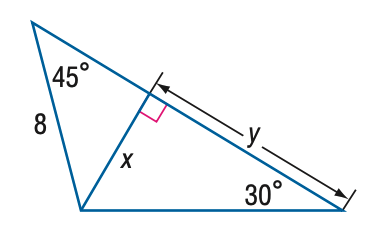Question: Find y.
Choices:
A. 4 \sqrt { 2 }
B. 4 \sqrt { 3 }
C. 4 \sqrt { 6 }
D. 8 \sqrt { 6 }
Answer with the letter. Answer: C 